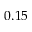Convert formula to latex. <formula><loc_0><loc_0><loc_500><loc_500>0 . 1 5</formula> 